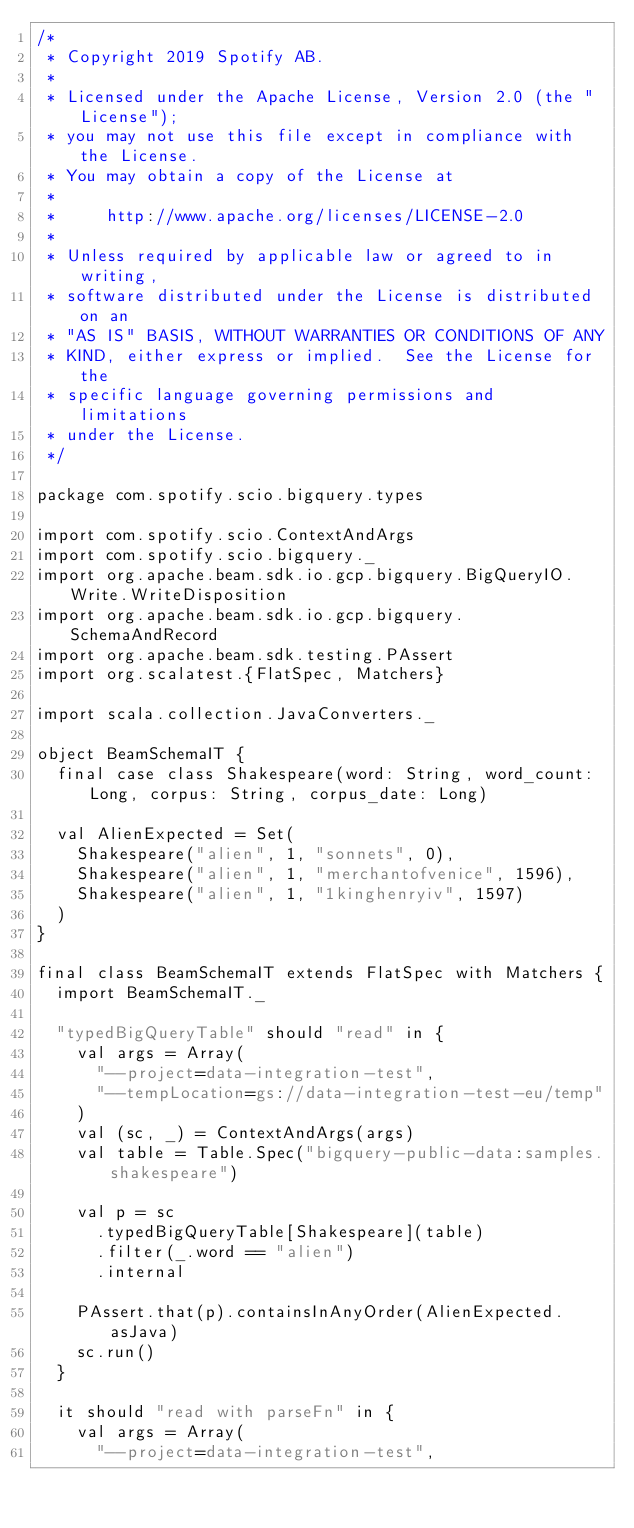<code> <loc_0><loc_0><loc_500><loc_500><_Scala_>/*
 * Copyright 2019 Spotify AB.
 *
 * Licensed under the Apache License, Version 2.0 (the "License");
 * you may not use this file except in compliance with the License.
 * You may obtain a copy of the License at
 *
 *     http://www.apache.org/licenses/LICENSE-2.0
 *
 * Unless required by applicable law or agreed to in writing,
 * software distributed under the License is distributed on an
 * "AS IS" BASIS, WITHOUT WARRANTIES OR CONDITIONS OF ANY
 * KIND, either express or implied.  See the License for the
 * specific language governing permissions and limitations
 * under the License.
 */

package com.spotify.scio.bigquery.types

import com.spotify.scio.ContextAndArgs
import com.spotify.scio.bigquery._
import org.apache.beam.sdk.io.gcp.bigquery.BigQueryIO.Write.WriteDisposition
import org.apache.beam.sdk.io.gcp.bigquery.SchemaAndRecord
import org.apache.beam.sdk.testing.PAssert
import org.scalatest.{FlatSpec, Matchers}

import scala.collection.JavaConverters._

object BeamSchemaIT {
  final case class Shakespeare(word: String, word_count: Long, corpus: String, corpus_date: Long)

  val AlienExpected = Set(
    Shakespeare("alien", 1, "sonnets", 0),
    Shakespeare("alien", 1, "merchantofvenice", 1596),
    Shakespeare("alien", 1, "1kinghenryiv", 1597)
  )
}

final class BeamSchemaIT extends FlatSpec with Matchers {
  import BeamSchemaIT._

  "typedBigQueryTable" should "read" in {
    val args = Array(
      "--project=data-integration-test",
      "--tempLocation=gs://data-integration-test-eu/temp"
    )
    val (sc, _) = ContextAndArgs(args)
    val table = Table.Spec("bigquery-public-data:samples.shakespeare")

    val p = sc
      .typedBigQueryTable[Shakespeare](table)
      .filter(_.word == "alien")
      .internal

    PAssert.that(p).containsInAnyOrder(AlienExpected.asJava)
    sc.run()
  }

  it should "read with parseFn" in {
    val args = Array(
      "--project=data-integration-test",</code> 